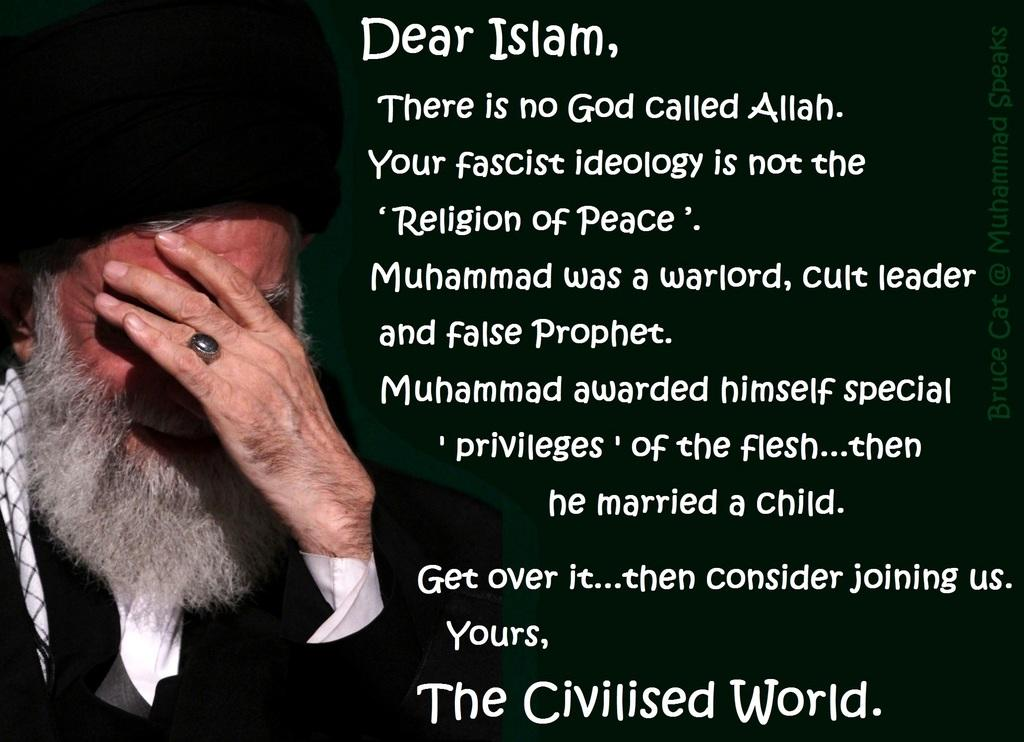What can be observed about the image that indicates it has been edited? The image is edited, which means it has been altered or manipulated in some way. What else is present in the image besides the edited content? There is text and a person in the image. Can you describe the text in the image? Unfortunately, without more information about the specific text, it is difficult to provide a detailed description. How does the person in the image compare to the authority figure in the room? There is no authority figure mentioned in the facts, so it's not possible to make a comparison between the person in the image and an authority figure. 